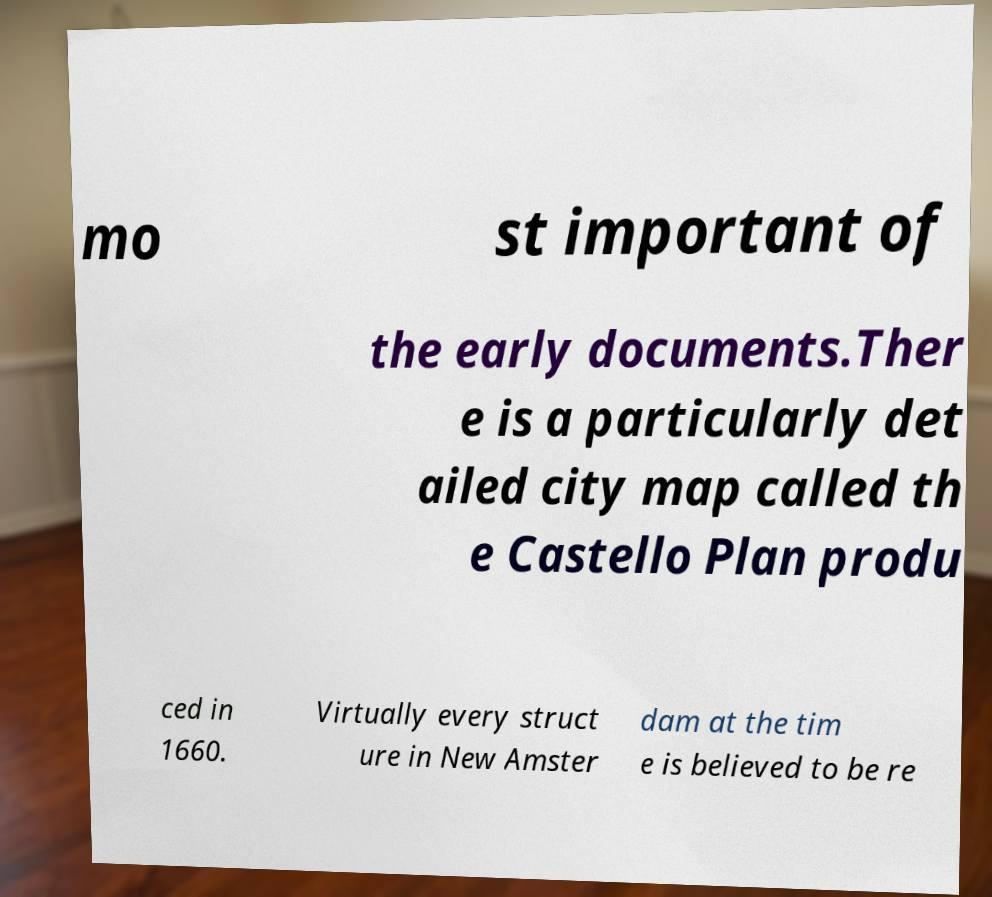There's text embedded in this image that I need extracted. Can you transcribe it verbatim? mo st important of the early documents.Ther e is a particularly det ailed city map called th e Castello Plan produ ced in 1660. Virtually every struct ure in New Amster dam at the tim e is believed to be re 